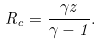<formula> <loc_0><loc_0><loc_500><loc_500>R _ { c } = \frac { \gamma z } { \gamma - 1 } .</formula> 